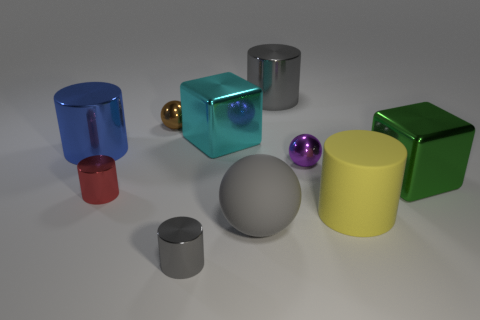Is the number of big gray rubber objects that are on the left side of the blue metallic cylinder the same as the number of yellow things in front of the tiny purple shiny sphere?
Provide a short and direct response. No. There is a gray metal thing in front of the small shiny cylinder behind the large cylinder in front of the red cylinder; what shape is it?
Ensure brevity in your answer.  Cylinder. Does the tiny ball that is on the right side of the tiny gray object have the same material as the big cylinder that is in front of the purple metal sphere?
Provide a short and direct response. No. The metal thing behind the brown metal thing has what shape?
Provide a short and direct response. Cylinder. Is the number of red shiny objects less than the number of gray shiny cylinders?
Your answer should be compact. Yes. Are there any large gray objects that are behind the large shiny cube that is to the right of the ball that is in front of the big green metallic block?
Ensure brevity in your answer.  Yes. How many rubber objects are either brown objects or purple things?
Provide a succinct answer. 0. There is a green metal cube; what number of small shiny objects are in front of it?
Provide a succinct answer. 2. How many tiny metal things are behind the small gray shiny cylinder and in front of the brown sphere?
Give a very brief answer. 2. The large blue object that is made of the same material as the purple thing is what shape?
Your answer should be compact. Cylinder. 